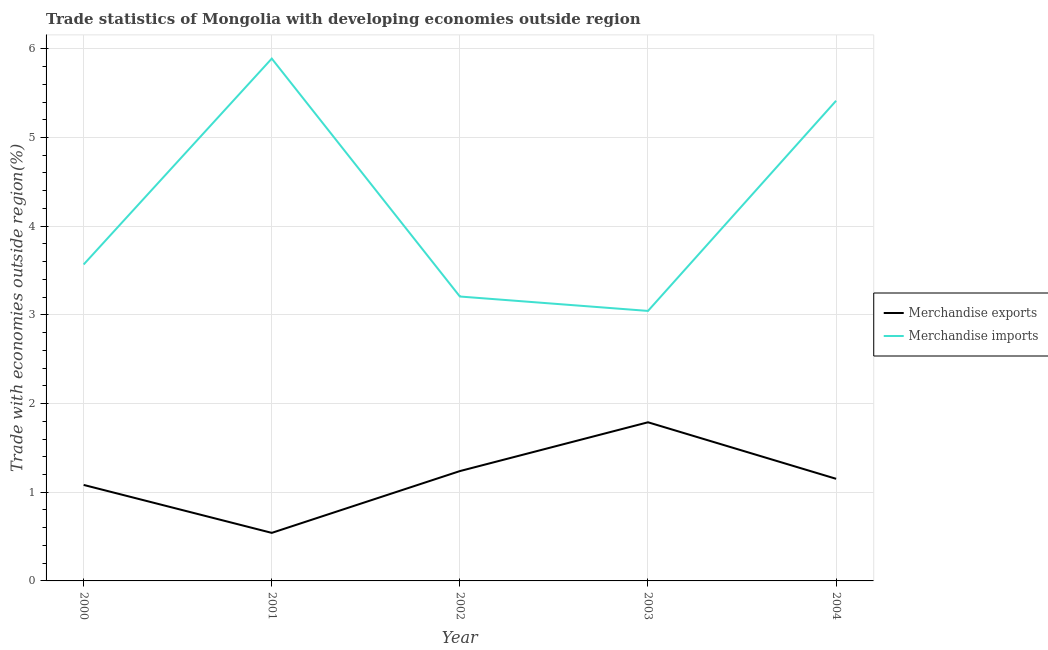Is the number of lines equal to the number of legend labels?
Offer a very short reply. Yes. What is the merchandise imports in 2001?
Offer a very short reply. 5.89. Across all years, what is the maximum merchandise exports?
Your response must be concise. 1.79. Across all years, what is the minimum merchandise imports?
Give a very brief answer. 3.04. What is the total merchandise exports in the graph?
Provide a short and direct response. 5.8. What is the difference between the merchandise imports in 2000 and that in 2004?
Ensure brevity in your answer.  -1.85. What is the difference between the merchandise exports in 2003 and the merchandise imports in 2004?
Offer a terse response. -3.63. What is the average merchandise exports per year?
Ensure brevity in your answer.  1.16. In the year 2003, what is the difference between the merchandise imports and merchandise exports?
Offer a very short reply. 1.26. In how many years, is the merchandise exports greater than 4.8 %?
Offer a terse response. 0. What is the ratio of the merchandise exports in 2000 to that in 2002?
Your response must be concise. 0.87. Is the merchandise imports in 2000 less than that in 2002?
Your response must be concise. No. Is the difference between the merchandise imports in 2000 and 2003 greater than the difference between the merchandise exports in 2000 and 2003?
Your answer should be compact. Yes. What is the difference between the highest and the second highest merchandise imports?
Make the answer very short. 0.48. What is the difference between the highest and the lowest merchandise exports?
Ensure brevity in your answer.  1.25. Is the sum of the merchandise exports in 2001 and 2004 greater than the maximum merchandise imports across all years?
Offer a terse response. No. Does the merchandise imports monotonically increase over the years?
Make the answer very short. No. Are the values on the major ticks of Y-axis written in scientific E-notation?
Make the answer very short. No. Does the graph contain any zero values?
Your answer should be very brief. No. Does the graph contain grids?
Provide a short and direct response. Yes. Where does the legend appear in the graph?
Your answer should be compact. Center right. How many legend labels are there?
Offer a very short reply. 2. How are the legend labels stacked?
Make the answer very short. Vertical. What is the title of the graph?
Give a very brief answer. Trade statistics of Mongolia with developing economies outside region. What is the label or title of the Y-axis?
Make the answer very short. Trade with economies outside region(%). What is the Trade with economies outside region(%) in Merchandise exports in 2000?
Offer a very short reply. 1.08. What is the Trade with economies outside region(%) in Merchandise imports in 2000?
Your response must be concise. 3.57. What is the Trade with economies outside region(%) of Merchandise exports in 2001?
Offer a very short reply. 0.54. What is the Trade with economies outside region(%) in Merchandise imports in 2001?
Keep it short and to the point. 5.89. What is the Trade with economies outside region(%) of Merchandise exports in 2002?
Provide a succinct answer. 1.24. What is the Trade with economies outside region(%) in Merchandise imports in 2002?
Ensure brevity in your answer.  3.21. What is the Trade with economies outside region(%) in Merchandise exports in 2003?
Give a very brief answer. 1.79. What is the Trade with economies outside region(%) in Merchandise imports in 2003?
Give a very brief answer. 3.04. What is the Trade with economies outside region(%) of Merchandise exports in 2004?
Keep it short and to the point. 1.15. What is the Trade with economies outside region(%) of Merchandise imports in 2004?
Your answer should be very brief. 5.41. Across all years, what is the maximum Trade with economies outside region(%) in Merchandise exports?
Your response must be concise. 1.79. Across all years, what is the maximum Trade with economies outside region(%) in Merchandise imports?
Your response must be concise. 5.89. Across all years, what is the minimum Trade with economies outside region(%) in Merchandise exports?
Your response must be concise. 0.54. Across all years, what is the minimum Trade with economies outside region(%) in Merchandise imports?
Offer a terse response. 3.04. What is the total Trade with economies outside region(%) in Merchandise exports in the graph?
Your answer should be very brief. 5.8. What is the total Trade with economies outside region(%) in Merchandise imports in the graph?
Offer a very short reply. 21.12. What is the difference between the Trade with economies outside region(%) in Merchandise exports in 2000 and that in 2001?
Keep it short and to the point. 0.54. What is the difference between the Trade with economies outside region(%) of Merchandise imports in 2000 and that in 2001?
Your response must be concise. -2.32. What is the difference between the Trade with economies outside region(%) of Merchandise exports in 2000 and that in 2002?
Provide a succinct answer. -0.16. What is the difference between the Trade with economies outside region(%) in Merchandise imports in 2000 and that in 2002?
Provide a short and direct response. 0.36. What is the difference between the Trade with economies outside region(%) of Merchandise exports in 2000 and that in 2003?
Your response must be concise. -0.71. What is the difference between the Trade with economies outside region(%) in Merchandise imports in 2000 and that in 2003?
Provide a short and direct response. 0.52. What is the difference between the Trade with economies outside region(%) of Merchandise exports in 2000 and that in 2004?
Provide a succinct answer. -0.07. What is the difference between the Trade with economies outside region(%) in Merchandise imports in 2000 and that in 2004?
Your answer should be compact. -1.85. What is the difference between the Trade with economies outside region(%) in Merchandise exports in 2001 and that in 2002?
Offer a very short reply. -0.7. What is the difference between the Trade with economies outside region(%) in Merchandise imports in 2001 and that in 2002?
Your answer should be compact. 2.68. What is the difference between the Trade with economies outside region(%) in Merchandise exports in 2001 and that in 2003?
Your answer should be compact. -1.25. What is the difference between the Trade with economies outside region(%) in Merchandise imports in 2001 and that in 2003?
Ensure brevity in your answer.  2.85. What is the difference between the Trade with economies outside region(%) in Merchandise exports in 2001 and that in 2004?
Your response must be concise. -0.61. What is the difference between the Trade with economies outside region(%) of Merchandise imports in 2001 and that in 2004?
Give a very brief answer. 0.48. What is the difference between the Trade with economies outside region(%) of Merchandise exports in 2002 and that in 2003?
Provide a succinct answer. -0.55. What is the difference between the Trade with economies outside region(%) of Merchandise imports in 2002 and that in 2003?
Offer a very short reply. 0.16. What is the difference between the Trade with economies outside region(%) of Merchandise exports in 2002 and that in 2004?
Keep it short and to the point. 0.09. What is the difference between the Trade with economies outside region(%) of Merchandise imports in 2002 and that in 2004?
Provide a succinct answer. -2.21. What is the difference between the Trade with economies outside region(%) of Merchandise exports in 2003 and that in 2004?
Offer a very short reply. 0.64. What is the difference between the Trade with economies outside region(%) in Merchandise imports in 2003 and that in 2004?
Your answer should be compact. -2.37. What is the difference between the Trade with economies outside region(%) in Merchandise exports in 2000 and the Trade with economies outside region(%) in Merchandise imports in 2001?
Your answer should be very brief. -4.81. What is the difference between the Trade with economies outside region(%) in Merchandise exports in 2000 and the Trade with economies outside region(%) in Merchandise imports in 2002?
Provide a succinct answer. -2.12. What is the difference between the Trade with economies outside region(%) in Merchandise exports in 2000 and the Trade with economies outside region(%) in Merchandise imports in 2003?
Offer a terse response. -1.96. What is the difference between the Trade with economies outside region(%) of Merchandise exports in 2000 and the Trade with economies outside region(%) of Merchandise imports in 2004?
Your answer should be very brief. -4.33. What is the difference between the Trade with economies outside region(%) in Merchandise exports in 2001 and the Trade with economies outside region(%) in Merchandise imports in 2002?
Your answer should be compact. -2.67. What is the difference between the Trade with economies outside region(%) in Merchandise exports in 2001 and the Trade with economies outside region(%) in Merchandise imports in 2003?
Offer a terse response. -2.5. What is the difference between the Trade with economies outside region(%) of Merchandise exports in 2001 and the Trade with economies outside region(%) of Merchandise imports in 2004?
Make the answer very short. -4.87. What is the difference between the Trade with economies outside region(%) in Merchandise exports in 2002 and the Trade with economies outside region(%) in Merchandise imports in 2003?
Offer a very short reply. -1.81. What is the difference between the Trade with economies outside region(%) of Merchandise exports in 2002 and the Trade with economies outside region(%) of Merchandise imports in 2004?
Your answer should be very brief. -4.18. What is the difference between the Trade with economies outside region(%) in Merchandise exports in 2003 and the Trade with economies outside region(%) in Merchandise imports in 2004?
Your response must be concise. -3.63. What is the average Trade with economies outside region(%) of Merchandise exports per year?
Make the answer very short. 1.16. What is the average Trade with economies outside region(%) in Merchandise imports per year?
Offer a very short reply. 4.22. In the year 2000, what is the difference between the Trade with economies outside region(%) in Merchandise exports and Trade with economies outside region(%) in Merchandise imports?
Ensure brevity in your answer.  -2.49. In the year 2001, what is the difference between the Trade with economies outside region(%) of Merchandise exports and Trade with economies outside region(%) of Merchandise imports?
Ensure brevity in your answer.  -5.35. In the year 2002, what is the difference between the Trade with economies outside region(%) in Merchandise exports and Trade with economies outside region(%) in Merchandise imports?
Give a very brief answer. -1.97. In the year 2003, what is the difference between the Trade with economies outside region(%) in Merchandise exports and Trade with economies outside region(%) in Merchandise imports?
Provide a succinct answer. -1.26. In the year 2004, what is the difference between the Trade with economies outside region(%) of Merchandise exports and Trade with economies outside region(%) of Merchandise imports?
Offer a terse response. -4.26. What is the ratio of the Trade with economies outside region(%) in Merchandise exports in 2000 to that in 2001?
Offer a terse response. 2. What is the ratio of the Trade with economies outside region(%) of Merchandise imports in 2000 to that in 2001?
Provide a short and direct response. 0.61. What is the ratio of the Trade with economies outside region(%) of Merchandise exports in 2000 to that in 2002?
Make the answer very short. 0.87. What is the ratio of the Trade with economies outside region(%) in Merchandise imports in 2000 to that in 2002?
Provide a succinct answer. 1.11. What is the ratio of the Trade with economies outside region(%) in Merchandise exports in 2000 to that in 2003?
Your answer should be compact. 0.61. What is the ratio of the Trade with economies outside region(%) of Merchandise imports in 2000 to that in 2003?
Provide a short and direct response. 1.17. What is the ratio of the Trade with economies outside region(%) in Merchandise exports in 2000 to that in 2004?
Offer a terse response. 0.94. What is the ratio of the Trade with economies outside region(%) of Merchandise imports in 2000 to that in 2004?
Offer a very short reply. 0.66. What is the ratio of the Trade with economies outside region(%) of Merchandise exports in 2001 to that in 2002?
Your answer should be very brief. 0.44. What is the ratio of the Trade with economies outside region(%) in Merchandise imports in 2001 to that in 2002?
Offer a very short reply. 1.84. What is the ratio of the Trade with economies outside region(%) in Merchandise exports in 2001 to that in 2003?
Offer a terse response. 0.3. What is the ratio of the Trade with economies outside region(%) in Merchandise imports in 2001 to that in 2003?
Your response must be concise. 1.93. What is the ratio of the Trade with economies outside region(%) in Merchandise exports in 2001 to that in 2004?
Offer a terse response. 0.47. What is the ratio of the Trade with economies outside region(%) of Merchandise imports in 2001 to that in 2004?
Ensure brevity in your answer.  1.09. What is the ratio of the Trade with economies outside region(%) of Merchandise exports in 2002 to that in 2003?
Offer a very short reply. 0.69. What is the ratio of the Trade with economies outside region(%) in Merchandise imports in 2002 to that in 2003?
Give a very brief answer. 1.05. What is the ratio of the Trade with economies outside region(%) of Merchandise exports in 2002 to that in 2004?
Ensure brevity in your answer.  1.08. What is the ratio of the Trade with economies outside region(%) in Merchandise imports in 2002 to that in 2004?
Your response must be concise. 0.59. What is the ratio of the Trade with economies outside region(%) of Merchandise exports in 2003 to that in 2004?
Your answer should be compact. 1.55. What is the ratio of the Trade with economies outside region(%) in Merchandise imports in 2003 to that in 2004?
Your answer should be compact. 0.56. What is the difference between the highest and the second highest Trade with economies outside region(%) of Merchandise exports?
Give a very brief answer. 0.55. What is the difference between the highest and the second highest Trade with economies outside region(%) of Merchandise imports?
Your answer should be very brief. 0.48. What is the difference between the highest and the lowest Trade with economies outside region(%) in Merchandise exports?
Provide a short and direct response. 1.25. What is the difference between the highest and the lowest Trade with economies outside region(%) of Merchandise imports?
Give a very brief answer. 2.85. 